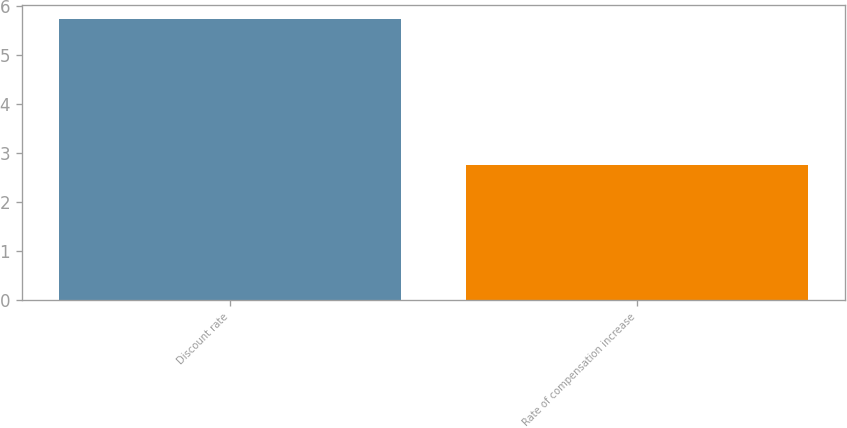Convert chart. <chart><loc_0><loc_0><loc_500><loc_500><bar_chart><fcel>Discount rate<fcel>Rate of compensation increase<nl><fcel>5.75<fcel>2.75<nl></chart> 